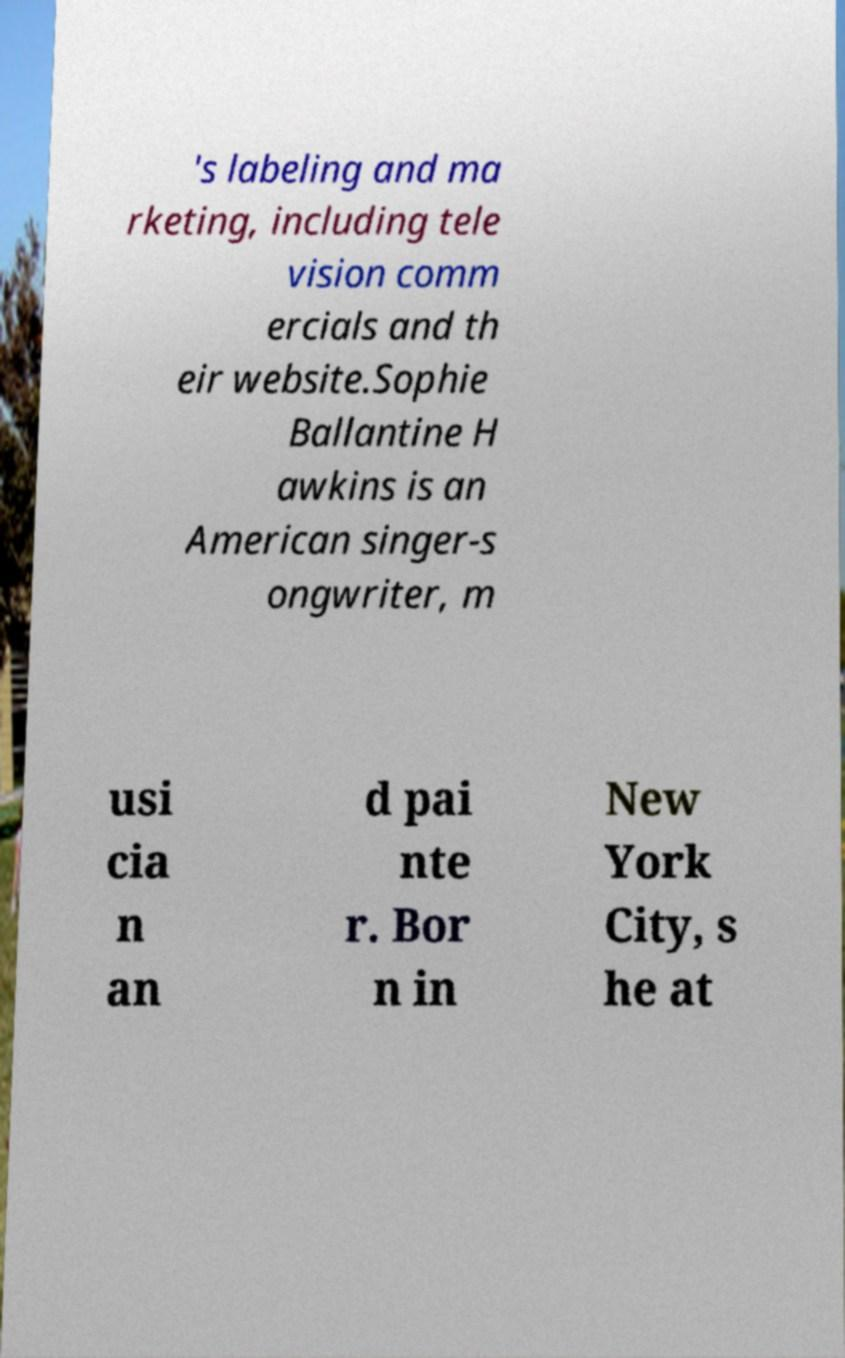What messages or text are displayed in this image? I need them in a readable, typed format. 's labeling and ma rketing, including tele vision comm ercials and th eir website.Sophie Ballantine H awkins is an American singer-s ongwriter, m usi cia n an d pai nte r. Bor n in New York City, s he at 